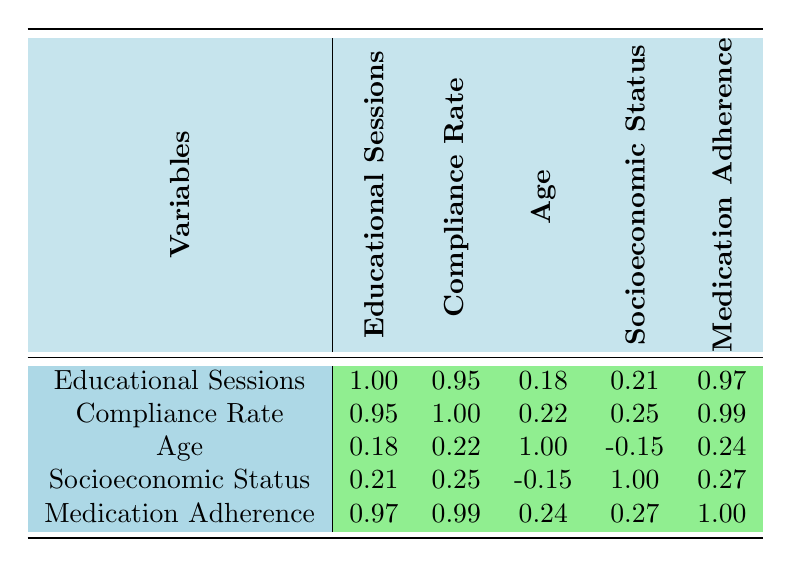What is the correlation between educational sessions and compliance rate? The correlation value between educational sessions and compliance rate is 0.95. This indicates a strong positive relationship, meaning as the number of educational sessions attended increases, the compliance rate also tends to increase.
Answer: 0.95 What is the correlation between medication adherence and compliance rate? The correlation value between medication adherence and compliance rate is 0.99. This is the highest correlation in the table, suggesting that higher medication adherence is strongly associated with higher compliance rates.
Answer: 0.99 Is there a significant correlation between age and compliance rate? The correlation between age and compliance rate is 0.22, which indicates a weak positive relationship. Therefore, it is not significant, suggesting age does not strongly influence compliance rate.
Answer: No What is the average compliance rate for the patients with middle socioeconomic status? From the table, the patients with middle socioeconomic status have compliance rates of 85% and 90%. The average is calculated by (85 + 90) / 2 = 87.5%.
Answer: 87.5% What can be inferred about the relationship between educational sessions and medication adherence based on the table? The correlation between educational sessions and medication adherence is 0.97, indicating a strong positive relationship. This suggests that as patients attend more educational sessions, their medication adherence scores also tend to be higher.
Answer: Strong positive relationship Which factor has the lowest correlation with age? The factor with the lowest correlation with age is socioeconomic status, with a correlation value of -0.15. This indicates a slight negative relationship, suggesting that age does not have a strong connection with socioeconomic status in this data set.
Answer: Socioeconomic status What is the correlation between socioeconomic status and compliance rate? The correlation value between socioeconomic status and compliance rate is 0.25, indicating a weak positive relationship. This means that there is a minor tendency for higher socioeconomic status to be associated with better compliance rates.
Answer: 0.25 Are patients who attended more educational sessions likely to have higher medication adherence scores? Yes, the correlation between educational sessions and medication adherence is 0.97, indicating a very strong positive relationship. This suggests that attending more sessions is likely related to higher adherence scores.
Answer: Yes 